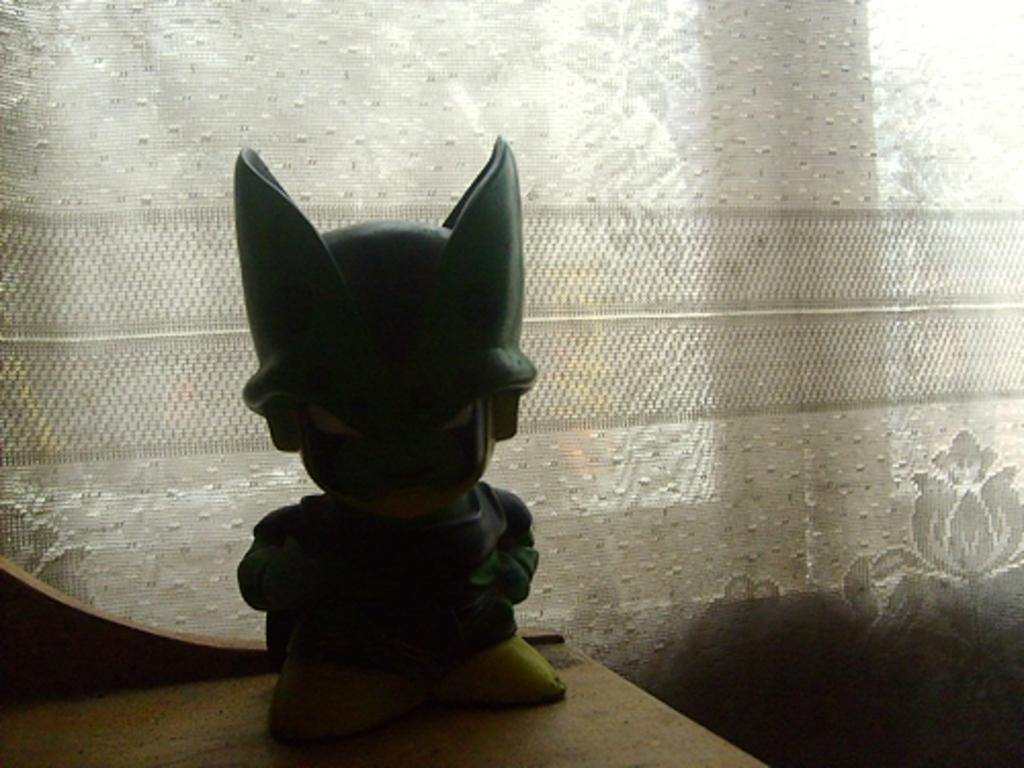What object is placed on the table in the image? There is a toy on the table in the image. What type of covering is present in the image? There is a curtain in the image. Where is the curtain attached? The curtain is attached to a wall. What type of vacation is being planned by the toy in the image? There is no indication in the image that the toy is planning a vacation, as toys do not have the ability to plan vacations. 